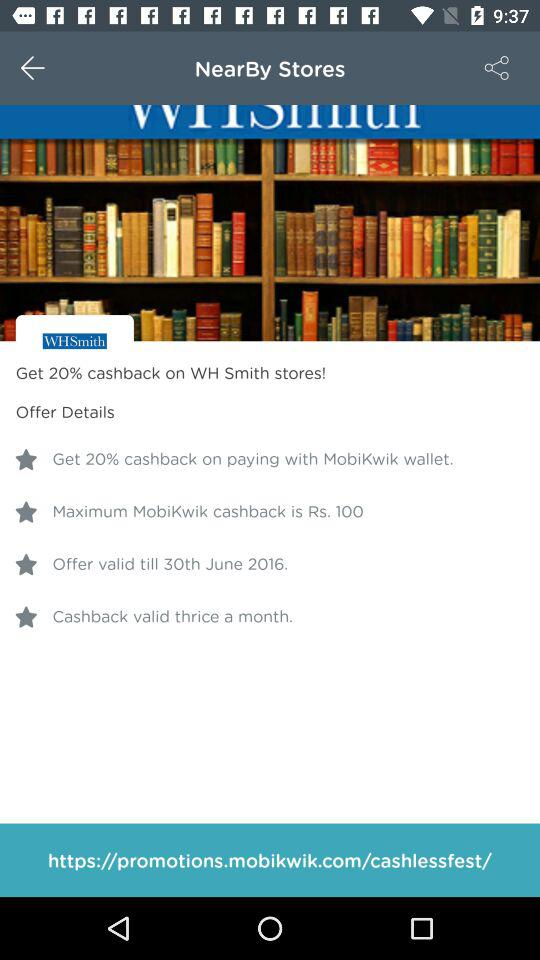How many cashback offers are available on this screen?
Answer the question using a single word or phrase. 4 